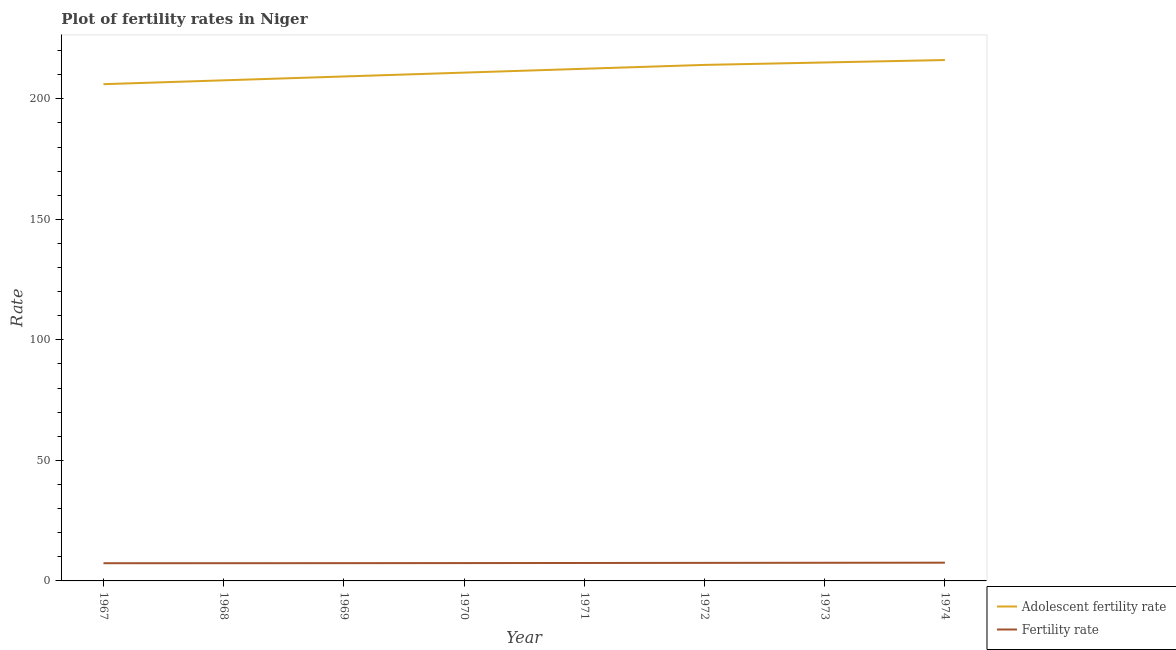Does the line corresponding to adolescent fertility rate intersect with the line corresponding to fertility rate?
Your answer should be very brief. No. Is the number of lines equal to the number of legend labels?
Your answer should be very brief. Yes. What is the fertility rate in 1971?
Offer a terse response. 7.44. Across all years, what is the maximum adolescent fertility rate?
Ensure brevity in your answer.  216.1. Across all years, what is the minimum adolescent fertility rate?
Give a very brief answer. 206.09. In which year was the adolescent fertility rate maximum?
Your response must be concise. 1974. In which year was the fertility rate minimum?
Provide a short and direct response. 1967. What is the total fertility rate in the graph?
Give a very brief answer. 59.48. What is the difference between the fertility rate in 1967 and that in 1971?
Offer a terse response. -0.1. What is the difference between the fertility rate in 1972 and the adolescent fertility rate in 1967?
Your answer should be compact. -198.6. What is the average adolescent fertility rate per year?
Give a very brief answer. 211.46. In the year 1973, what is the difference between the fertility rate and adolescent fertility rate?
Provide a succinct answer. -207.57. What is the ratio of the adolescent fertility rate in 1969 to that in 1973?
Offer a very short reply. 0.97. Is the fertility rate in 1970 less than that in 1971?
Provide a succinct answer. Yes. What is the difference between the highest and the second highest fertility rate?
Ensure brevity in your answer.  0.04. What is the difference between the highest and the lowest fertility rate?
Make the answer very short. 0.22. In how many years, is the adolescent fertility rate greater than the average adolescent fertility rate taken over all years?
Make the answer very short. 4. Is the sum of the adolescent fertility rate in 1971 and 1974 greater than the maximum fertility rate across all years?
Keep it short and to the point. Yes. Is the fertility rate strictly less than the adolescent fertility rate over the years?
Ensure brevity in your answer.  Yes. How many years are there in the graph?
Keep it short and to the point. 8. Are the values on the major ticks of Y-axis written in scientific E-notation?
Provide a succinct answer. No. Does the graph contain any zero values?
Make the answer very short. No. Does the graph contain grids?
Offer a terse response. No. How many legend labels are there?
Provide a succinct answer. 2. What is the title of the graph?
Your response must be concise. Plot of fertility rates in Niger. What is the label or title of the X-axis?
Provide a succinct answer. Year. What is the label or title of the Y-axis?
Offer a very short reply. Rate. What is the Rate in Adolescent fertility rate in 1967?
Your answer should be compact. 206.09. What is the Rate of Fertility rate in 1967?
Keep it short and to the point. 7.34. What is the Rate of Adolescent fertility rate in 1968?
Provide a short and direct response. 207.69. What is the Rate of Fertility rate in 1968?
Give a very brief answer. 7.35. What is the Rate in Adolescent fertility rate in 1969?
Make the answer very short. 209.29. What is the Rate of Fertility rate in 1969?
Your answer should be compact. 7.37. What is the Rate in Adolescent fertility rate in 1970?
Offer a terse response. 210.88. What is the Rate in Adolescent fertility rate in 1971?
Give a very brief answer. 212.48. What is the Rate in Fertility rate in 1971?
Your response must be concise. 7.44. What is the Rate of Adolescent fertility rate in 1972?
Make the answer very short. 214.08. What is the Rate of Fertility rate in 1972?
Provide a succinct answer. 7.48. What is the Rate in Adolescent fertility rate in 1973?
Provide a short and direct response. 215.09. What is the Rate of Fertility rate in 1973?
Give a very brief answer. 7.53. What is the Rate in Adolescent fertility rate in 1974?
Make the answer very short. 216.1. What is the Rate in Fertility rate in 1974?
Ensure brevity in your answer.  7.56. Across all years, what is the maximum Rate of Adolescent fertility rate?
Give a very brief answer. 216.1. Across all years, what is the maximum Rate of Fertility rate?
Keep it short and to the point. 7.56. Across all years, what is the minimum Rate of Adolescent fertility rate?
Your response must be concise. 206.09. Across all years, what is the minimum Rate in Fertility rate?
Ensure brevity in your answer.  7.34. What is the total Rate in Adolescent fertility rate in the graph?
Make the answer very short. 1691.71. What is the total Rate in Fertility rate in the graph?
Your answer should be very brief. 59.48. What is the difference between the Rate in Adolescent fertility rate in 1967 and that in 1968?
Offer a very short reply. -1.6. What is the difference between the Rate in Fertility rate in 1967 and that in 1968?
Provide a short and direct response. -0.01. What is the difference between the Rate in Adolescent fertility rate in 1967 and that in 1969?
Your response must be concise. -3.2. What is the difference between the Rate in Fertility rate in 1967 and that in 1969?
Provide a short and direct response. -0.02. What is the difference between the Rate of Adolescent fertility rate in 1967 and that in 1970?
Offer a terse response. -4.8. What is the difference between the Rate of Fertility rate in 1967 and that in 1970?
Your answer should be very brief. -0.06. What is the difference between the Rate in Adolescent fertility rate in 1967 and that in 1971?
Ensure brevity in your answer.  -6.39. What is the difference between the Rate of Fertility rate in 1967 and that in 1971?
Your answer should be very brief. -0.1. What is the difference between the Rate in Adolescent fertility rate in 1967 and that in 1972?
Keep it short and to the point. -7.99. What is the difference between the Rate in Fertility rate in 1967 and that in 1972?
Provide a succinct answer. -0.14. What is the difference between the Rate in Adolescent fertility rate in 1967 and that in 1973?
Provide a succinct answer. -9. What is the difference between the Rate of Fertility rate in 1967 and that in 1973?
Ensure brevity in your answer.  -0.18. What is the difference between the Rate of Adolescent fertility rate in 1967 and that in 1974?
Make the answer very short. -10.02. What is the difference between the Rate of Fertility rate in 1967 and that in 1974?
Offer a very short reply. -0.22. What is the difference between the Rate in Adolescent fertility rate in 1968 and that in 1969?
Offer a very short reply. -1.6. What is the difference between the Rate of Fertility rate in 1968 and that in 1969?
Your answer should be compact. -0.02. What is the difference between the Rate of Adolescent fertility rate in 1968 and that in 1970?
Provide a short and direct response. -3.2. What is the difference between the Rate of Adolescent fertility rate in 1968 and that in 1971?
Your response must be concise. -4.8. What is the difference between the Rate in Fertility rate in 1968 and that in 1971?
Ensure brevity in your answer.  -0.09. What is the difference between the Rate of Adolescent fertility rate in 1968 and that in 1972?
Offer a terse response. -6.39. What is the difference between the Rate of Fertility rate in 1968 and that in 1972?
Provide a short and direct response. -0.13. What is the difference between the Rate in Adolescent fertility rate in 1968 and that in 1973?
Your answer should be compact. -7.41. What is the difference between the Rate in Fertility rate in 1968 and that in 1973?
Ensure brevity in your answer.  -0.18. What is the difference between the Rate of Adolescent fertility rate in 1968 and that in 1974?
Offer a very short reply. -8.42. What is the difference between the Rate of Fertility rate in 1968 and that in 1974?
Your response must be concise. -0.21. What is the difference between the Rate in Adolescent fertility rate in 1969 and that in 1970?
Ensure brevity in your answer.  -1.6. What is the difference between the Rate of Fertility rate in 1969 and that in 1970?
Offer a terse response. -0.03. What is the difference between the Rate in Adolescent fertility rate in 1969 and that in 1971?
Give a very brief answer. -3.2. What is the difference between the Rate of Fertility rate in 1969 and that in 1971?
Your response must be concise. -0.07. What is the difference between the Rate of Adolescent fertility rate in 1969 and that in 1972?
Provide a short and direct response. -4.8. What is the difference between the Rate of Fertility rate in 1969 and that in 1972?
Keep it short and to the point. -0.12. What is the difference between the Rate of Adolescent fertility rate in 1969 and that in 1973?
Offer a very short reply. -5.81. What is the difference between the Rate in Fertility rate in 1969 and that in 1973?
Your answer should be compact. -0.16. What is the difference between the Rate of Adolescent fertility rate in 1969 and that in 1974?
Give a very brief answer. -6.82. What is the difference between the Rate of Fertility rate in 1969 and that in 1974?
Ensure brevity in your answer.  -0.19. What is the difference between the Rate of Adolescent fertility rate in 1970 and that in 1971?
Your response must be concise. -1.6. What is the difference between the Rate of Fertility rate in 1970 and that in 1971?
Provide a succinct answer. -0.04. What is the difference between the Rate in Adolescent fertility rate in 1970 and that in 1972?
Ensure brevity in your answer.  -3.2. What is the difference between the Rate in Fertility rate in 1970 and that in 1972?
Make the answer very short. -0.08. What is the difference between the Rate in Adolescent fertility rate in 1970 and that in 1973?
Provide a succinct answer. -4.21. What is the difference between the Rate in Fertility rate in 1970 and that in 1973?
Offer a terse response. -0.13. What is the difference between the Rate of Adolescent fertility rate in 1970 and that in 1974?
Your response must be concise. -5.22. What is the difference between the Rate in Fertility rate in 1970 and that in 1974?
Your answer should be compact. -0.16. What is the difference between the Rate in Adolescent fertility rate in 1971 and that in 1972?
Offer a very short reply. -1.6. What is the difference between the Rate of Fertility rate in 1971 and that in 1972?
Make the answer very short. -0.04. What is the difference between the Rate of Adolescent fertility rate in 1971 and that in 1973?
Make the answer very short. -2.61. What is the difference between the Rate of Fertility rate in 1971 and that in 1973?
Give a very brief answer. -0.09. What is the difference between the Rate of Adolescent fertility rate in 1971 and that in 1974?
Ensure brevity in your answer.  -3.62. What is the difference between the Rate in Fertility rate in 1971 and that in 1974?
Provide a succinct answer. -0.12. What is the difference between the Rate of Adolescent fertility rate in 1972 and that in 1973?
Offer a terse response. -1.01. What is the difference between the Rate in Fertility rate in 1972 and that in 1973?
Provide a short and direct response. -0.04. What is the difference between the Rate in Adolescent fertility rate in 1972 and that in 1974?
Your response must be concise. -2.02. What is the difference between the Rate in Fertility rate in 1972 and that in 1974?
Keep it short and to the point. -0.08. What is the difference between the Rate in Adolescent fertility rate in 1973 and that in 1974?
Make the answer very short. -1.01. What is the difference between the Rate in Fertility rate in 1973 and that in 1974?
Give a very brief answer. -0.04. What is the difference between the Rate in Adolescent fertility rate in 1967 and the Rate in Fertility rate in 1968?
Your answer should be compact. 198.74. What is the difference between the Rate of Adolescent fertility rate in 1967 and the Rate of Fertility rate in 1969?
Your answer should be compact. 198.72. What is the difference between the Rate in Adolescent fertility rate in 1967 and the Rate in Fertility rate in 1970?
Offer a very short reply. 198.69. What is the difference between the Rate in Adolescent fertility rate in 1967 and the Rate in Fertility rate in 1971?
Offer a very short reply. 198.65. What is the difference between the Rate in Adolescent fertility rate in 1967 and the Rate in Fertility rate in 1972?
Your answer should be compact. 198.6. What is the difference between the Rate of Adolescent fertility rate in 1967 and the Rate of Fertility rate in 1973?
Offer a terse response. 198.56. What is the difference between the Rate in Adolescent fertility rate in 1967 and the Rate in Fertility rate in 1974?
Give a very brief answer. 198.53. What is the difference between the Rate of Adolescent fertility rate in 1968 and the Rate of Fertility rate in 1969?
Your answer should be compact. 200.32. What is the difference between the Rate in Adolescent fertility rate in 1968 and the Rate in Fertility rate in 1970?
Provide a succinct answer. 200.29. What is the difference between the Rate in Adolescent fertility rate in 1968 and the Rate in Fertility rate in 1971?
Ensure brevity in your answer.  200.25. What is the difference between the Rate of Adolescent fertility rate in 1968 and the Rate of Fertility rate in 1972?
Your response must be concise. 200.2. What is the difference between the Rate in Adolescent fertility rate in 1968 and the Rate in Fertility rate in 1973?
Offer a terse response. 200.16. What is the difference between the Rate in Adolescent fertility rate in 1968 and the Rate in Fertility rate in 1974?
Offer a terse response. 200.13. What is the difference between the Rate in Adolescent fertility rate in 1969 and the Rate in Fertility rate in 1970?
Keep it short and to the point. 201.89. What is the difference between the Rate of Adolescent fertility rate in 1969 and the Rate of Fertility rate in 1971?
Offer a terse response. 201.84. What is the difference between the Rate of Adolescent fertility rate in 1969 and the Rate of Fertility rate in 1972?
Your answer should be compact. 201.8. What is the difference between the Rate in Adolescent fertility rate in 1969 and the Rate in Fertility rate in 1973?
Give a very brief answer. 201.76. What is the difference between the Rate in Adolescent fertility rate in 1969 and the Rate in Fertility rate in 1974?
Make the answer very short. 201.72. What is the difference between the Rate of Adolescent fertility rate in 1970 and the Rate of Fertility rate in 1971?
Provide a succinct answer. 203.44. What is the difference between the Rate in Adolescent fertility rate in 1970 and the Rate in Fertility rate in 1972?
Your answer should be very brief. 203.4. What is the difference between the Rate in Adolescent fertility rate in 1970 and the Rate in Fertility rate in 1973?
Offer a terse response. 203.36. What is the difference between the Rate in Adolescent fertility rate in 1970 and the Rate in Fertility rate in 1974?
Ensure brevity in your answer.  203.32. What is the difference between the Rate in Adolescent fertility rate in 1971 and the Rate in Fertility rate in 1972?
Keep it short and to the point. 205. What is the difference between the Rate in Adolescent fertility rate in 1971 and the Rate in Fertility rate in 1973?
Ensure brevity in your answer.  204.96. What is the difference between the Rate in Adolescent fertility rate in 1971 and the Rate in Fertility rate in 1974?
Provide a short and direct response. 204.92. What is the difference between the Rate of Adolescent fertility rate in 1972 and the Rate of Fertility rate in 1973?
Make the answer very short. 206.56. What is the difference between the Rate in Adolescent fertility rate in 1972 and the Rate in Fertility rate in 1974?
Your answer should be compact. 206.52. What is the difference between the Rate of Adolescent fertility rate in 1973 and the Rate of Fertility rate in 1974?
Ensure brevity in your answer.  207.53. What is the average Rate of Adolescent fertility rate per year?
Give a very brief answer. 211.46. What is the average Rate of Fertility rate per year?
Make the answer very short. 7.43. In the year 1967, what is the difference between the Rate in Adolescent fertility rate and Rate in Fertility rate?
Your answer should be very brief. 198.74. In the year 1968, what is the difference between the Rate in Adolescent fertility rate and Rate in Fertility rate?
Keep it short and to the point. 200.34. In the year 1969, what is the difference between the Rate in Adolescent fertility rate and Rate in Fertility rate?
Offer a terse response. 201.92. In the year 1970, what is the difference between the Rate in Adolescent fertility rate and Rate in Fertility rate?
Your answer should be compact. 203.48. In the year 1971, what is the difference between the Rate in Adolescent fertility rate and Rate in Fertility rate?
Provide a succinct answer. 205.04. In the year 1972, what is the difference between the Rate of Adolescent fertility rate and Rate of Fertility rate?
Give a very brief answer. 206.6. In the year 1973, what is the difference between the Rate of Adolescent fertility rate and Rate of Fertility rate?
Give a very brief answer. 207.57. In the year 1974, what is the difference between the Rate of Adolescent fertility rate and Rate of Fertility rate?
Your answer should be very brief. 208.54. What is the ratio of the Rate in Fertility rate in 1967 to that in 1968?
Offer a very short reply. 1. What is the ratio of the Rate of Adolescent fertility rate in 1967 to that in 1969?
Give a very brief answer. 0.98. What is the ratio of the Rate in Fertility rate in 1967 to that in 1969?
Make the answer very short. 1. What is the ratio of the Rate of Adolescent fertility rate in 1967 to that in 1970?
Make the answer very short. 0.98. What is the ratio of the Rate of Adolescent fertility rate in 1967 to that in 1971?
Provide a short and direct response. 0.97. What is the ratio of the Rate of Fertility rate in 1967 to that in 1971?
Offer a very short reply. 0.99. What is the ratio of the Rate of Adolescent fertility rate in 1967 to that in 1972?
Provide a short and direct response. 0.96. What is the ratio of the Rate of Fertility rate in 1967 to that in 1972?
Make the answer very short. 0.98. What is the ratio of the Rate in Adolescent fertility rate in 1967 to that in 1973?
Offer a very short reply. 0.96. What is the ratio of the Rate in Adolescent fertility rate in 1967 to that in 1974?
Give a very brief answer. 0.95. What is the ratio of the Rate of Fertility rate in 1967 to that in 1974?
Ensure brevity in your answer.  0.97. What is the ratio of the Rate in Fertility rate in 1968 to that in 1970?
Offer a terse response. 0.99. What is the ratio of the Rate of Adolescent fertility rate in 1968 to that in 1971?
Your answer should be compact. 0.98. What is the ratio of the Rate in Fertility rate in 1968 to that in 1971?
Keep it short and to the point. 0.99. What is the ratio of the Rate of Adolescent fertility rate in 1968 to that in 1972?
Your response must be concise. 0.97. What is the ratio of the Rate in Fertility rate in 1968 to that in 1972?
Provide a short and direct response. 0.98. What is the ratio of the Rate in Adolescent fertility rate in 1968 to that in 1973?
Give a very brief answer. 0.97. What is the ratio of the Rate in Fertility rate in 1968 to that in 1973?
Make the answer very short. 0.98. What is the ratio of the Rate of Adolescent fertility rate in 1968 to that in 1974?
Ensure brevity in your answer.  0.96. What is the ratio of the Rate of Adolescent fertility rate in 1969 to that in 1970?
Make the answer very short. 0.99. What is the ratio of the Rate in Fertility rate in 1969 to that in 1971?
Your answer should be very brief. 0.99. What is the ratio of the Rate of Adolescent fertility rate in 1969 to that in 1972?
Offer a terse response. 0.98. What is the ratio of the Rate of Fertility rate in 1969 to that in 1972?
Give a very brief answer. 0.98. What is the ratio of the Rate in Fertility rate in 1969 to that in 1973?
Ensure brevity in your answer.  0.98. What is the ratio of the Rate in Adolescent fertility rate in 1969 to that in 1974?
Ensure brevity in your answer.  0.97. What is the ratio of the Rate in Fertility rate in 1969 to that in 1974?
Provide a succinct answer. 0.97. What is the ratio of the Rate in Fertility rate in 1970 to that in 1971?
Offer a very short reply. 0.99. What is the ratio of the Rate in Adolescent fertility rate in 1970 to that in 1972?
Offer a terse response. 0.99. What is the ratio of the Rate of Adolescent fertility rate in 1970 to that in 1973?
Make the answer very short. 0.98. What is the ratio of the Rate of Fertility rate in 1970 to that in 1973?
Offer a terse response. 0.98. What is the ratio of the Rate of Adolescent fertility rate in 1970 to that in 1974?
Ensure brevity in your answer.  0.98. What is the ratio of the Rate of Fertility rate in 1970 to that in 1974?
Make the answer very short. 0.98. What is the ratio of the Rate in Fertility rate in 1971 to that in 1972?
Make the answer very short. 0.99. What is the ratio of the Rate of Adolescent fertility rate in 1971 to that in 1973?
Provide a short and direct response. 0.99. What is the ratio of the Rate in Fertility rate in 1971 to that in 1973?
Ensure brevity in your answer.  0.99. What is the ratio of the Rate of Adolescent fertility rate in 1971 to that in 1974?
Give a very brief answer. 0.98. What is the ratio of the Rate in Fertility rate in 1971 to that in 1974?
Offer a terse response. 0.98. What is the ratio of the Rate in Adolescent fertility rate in 1972 to that in 1974?
Your answer should be compact. 0.99. What is the ratio of the Rate in Fertility rate in 1972 to that in 1974?
Give a very brief answer. 0.99. What is the difference between the highest and the second highest Rate of Adolescent fertility rate?
Offer a very short reply. 1.01. What is the difference between the highest and the second highest Rate of Fertility rate?
Make the answer very short. 0.04. What is the difference between the highest and the lowest Rate of Adolescent fertility rate?
Offer a terse response. 10.02. What is the difference between the highest and the lowest Rate in Fertility rate?
Offer a very short reply. 0.22. 